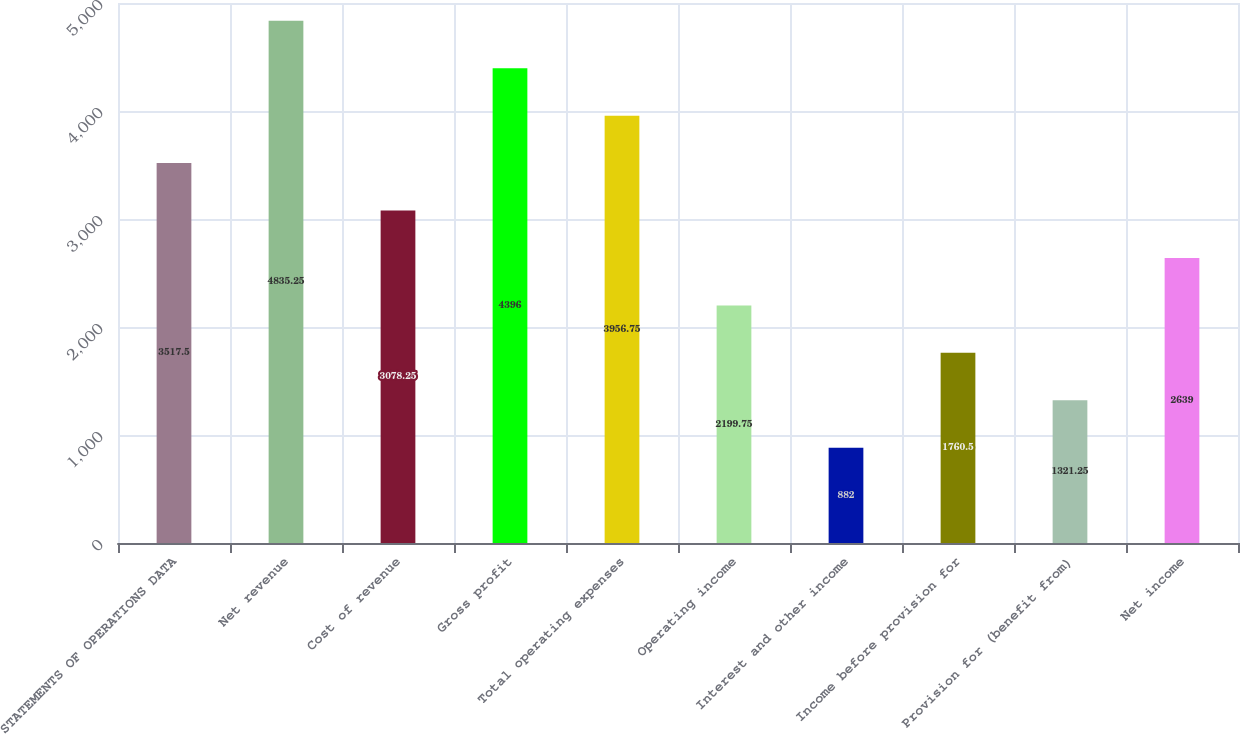Convert chart to OTSL. <chart><loc_0><loc_0><loc_500><loc_500><bar_chart><fcel>STATEMENTS OF OPERATIONS DATA<fcel>Net revenue<fcel>Cost of revenue<fcel>Gross profit<fcel>Total operating expenses<fcel>Operating income<fcel>Interest and other income<fcel>Income before provision for<fcel>Provision for (benefit from)<fcel>Net income<nl><fcel>3517.5<fcel>4835.25<fcel>3078.25<fcel>4396<fcel>3956.75<fcel>2199.75<fcel>882<fcel>1760.5<fcel>1321.25<fcel>2639<nl></chart> 